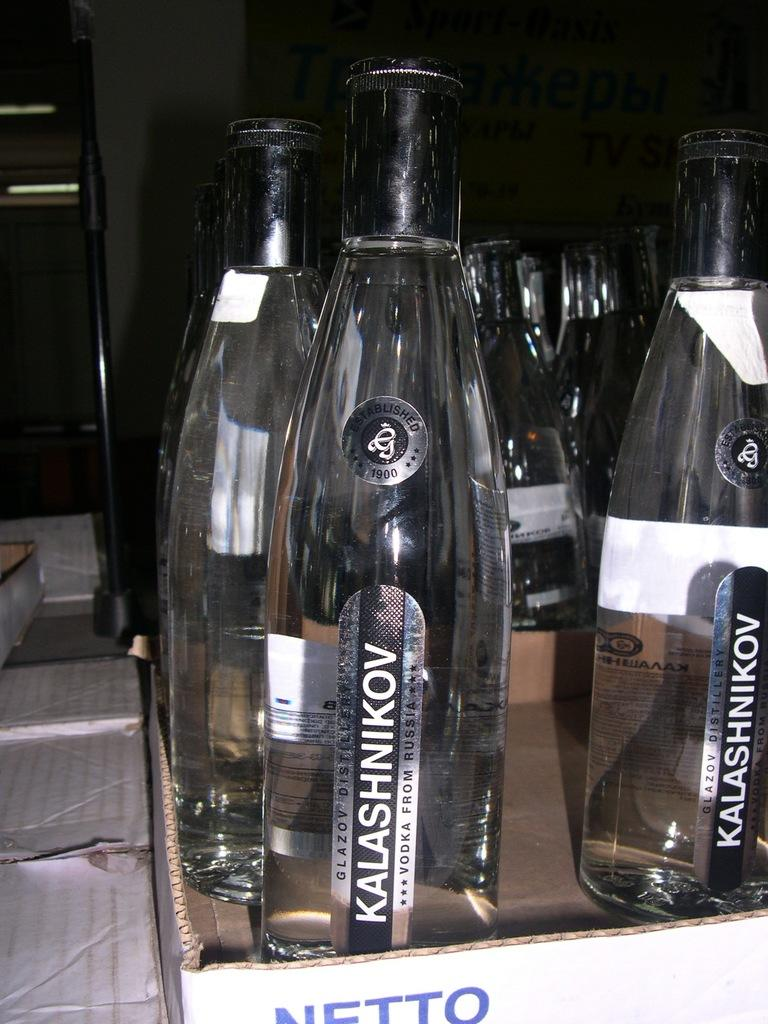<image>
Offer a succinct explanation of the picture presented. A group of identical bottles that say Kalashnikov are in a cardboard box that says Netto. 